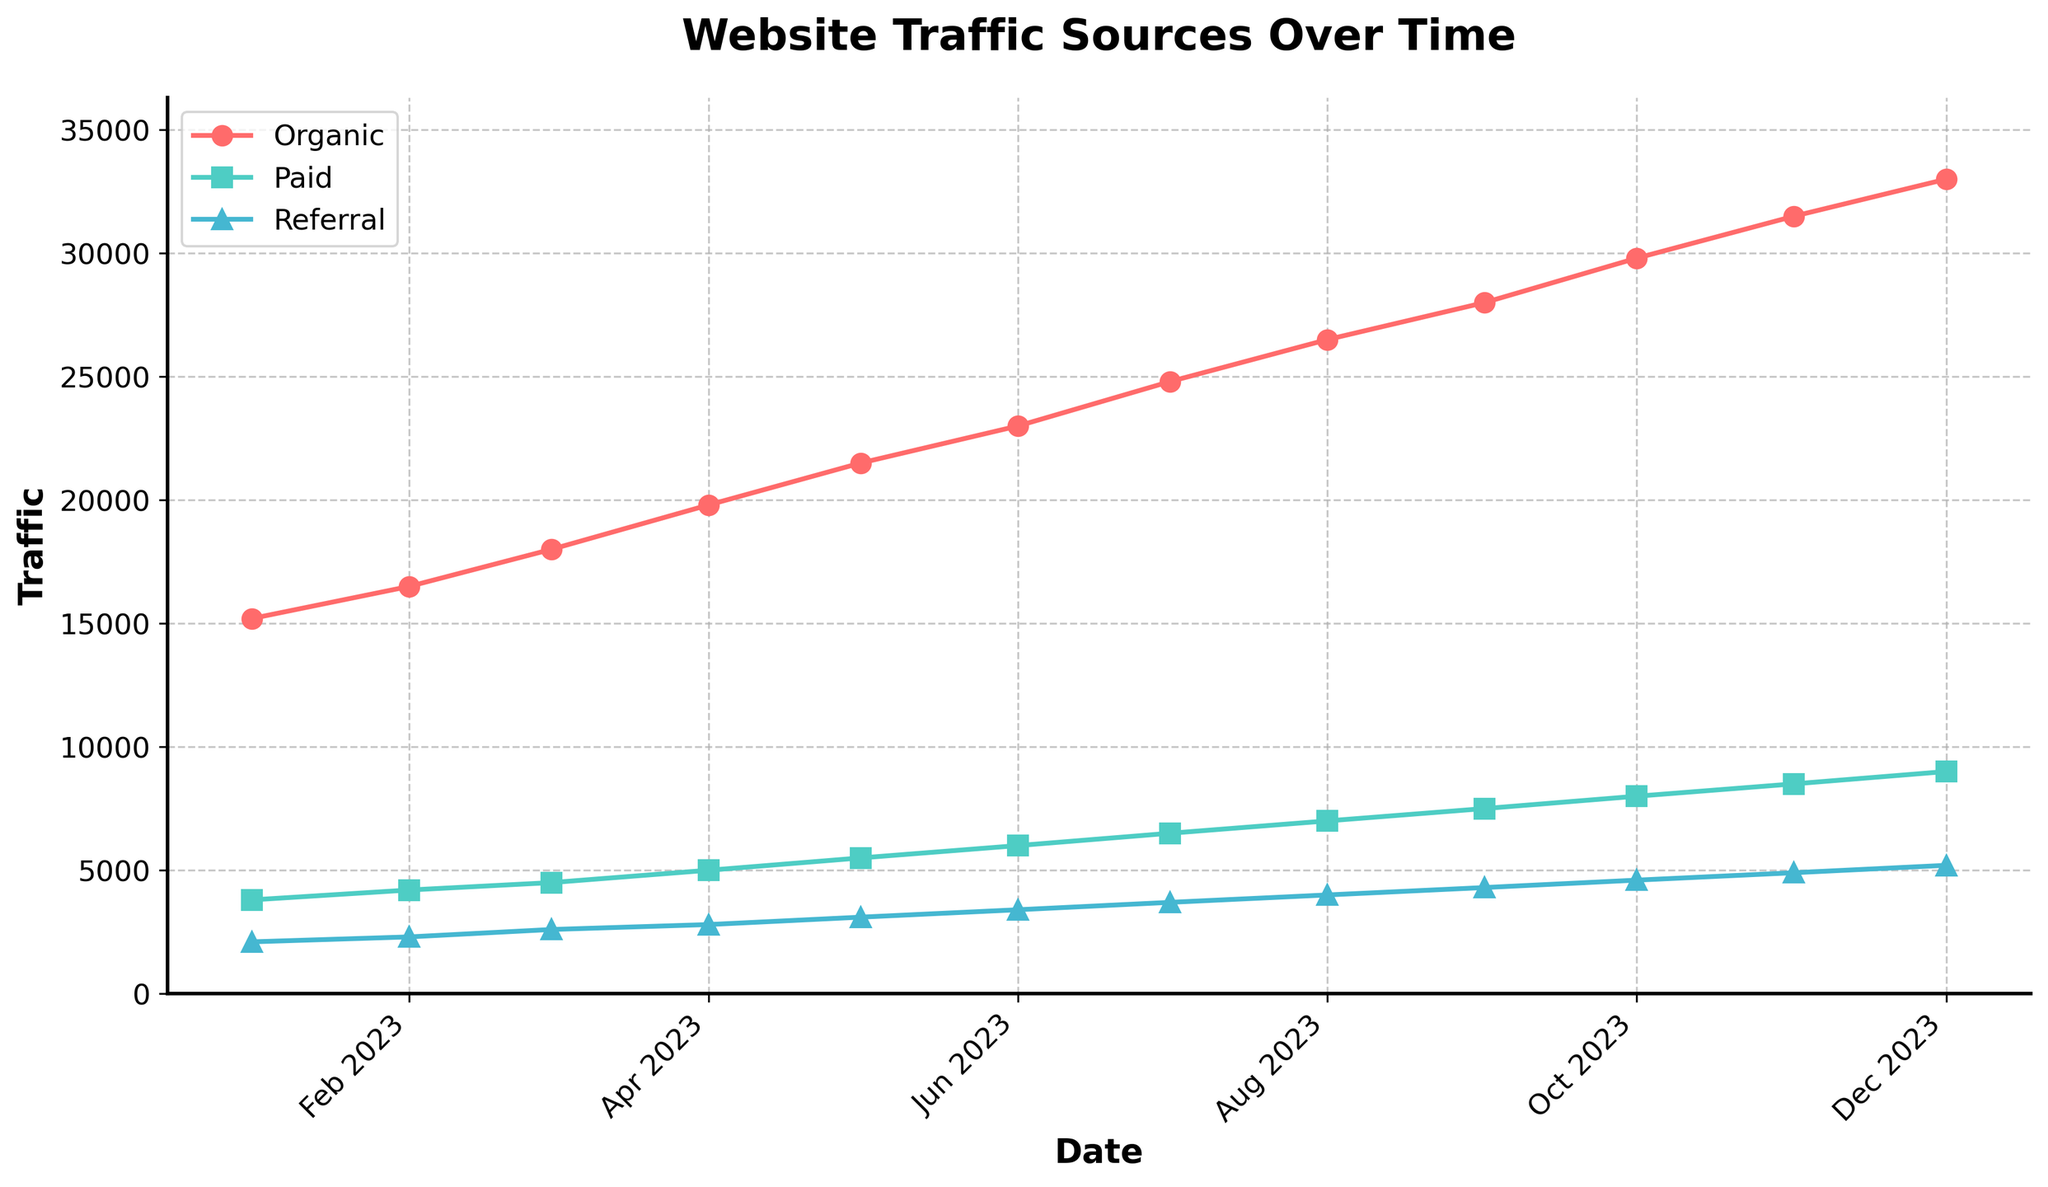Which traffic source had the highest value in December 2023? In December 2023, the highest value needs to be determined among Organic, Paid, and Referral traffic. By examining the data points for December on the plot, we see that Organic Traffic is at 33,000, Paid Traffic is at 9,000, and Referral Traffic is at 5,200. The highest value is for Organic Traffic.
Answer: Organic Traffic How has Organic Traffic trended over the year? To understand the trend of Organic Traffic over the year, observe the line that represents it. The line shows a consistent upward trend from January (15,200) to December (33,000), indicating a steady increase.
Answer: Increasing In which month was the increase in Paid Traffic the highest? Find the month-to-month increase in Paid Traffic by looking at the month-on-month values in the plot. The highest increase can be observed by comparing each month's values. Notably, between November (8,500) and December (9,000), the increase is 500.
Answer: December Which source of traffic had the smallest growth rate in May 2023 compared to January 2023? To find the smallest growth rate, calculate the difference for each traffic source between January and May, then divide by the January value. Organic Traffic increased by (21,500 - 15,200) / 15,200 = 41.4%; Paid Traffic increased by (5,500 - 3,800) / 3,800 = 44.7%; Referral Traffic increased by (3,100 - 2,100) / 2,100 = 47.6%. The smallest growth rate is for Organic Traffic.
Answer: Organic Traffic By how much did Referral Traffic exceed 4,000? Determine the month where Referral Traffic first exceeds 4,000 by examining the plotted points. Referral Traffic exceeds 4,000 in August 2023.
Answer: 700 Comparing April 2023, which traffic source had the closest value to Referral Traffic? In April 2023, refer to the plot values: Referral Traffic is 2,800, Organic Traffic is 19,800, and Paid Traffic is 5,000. Calculate the difference with Referral Traffic. The closest value to 2,800 is Paid Traffic (5,000 - 2,800 = 2,200).
Answer: Paid Traffic Which traffic source shows an almost linear increase throughout the year? To determine linearity, observe the consistency of spacing between data points for each traffic source. Organic Traffic appears to have a roughly linear increase as the intervals between each data point from January to December are consistent.
Answer: Organic Traffic What is the combined traffic from all sources in July 2023? Sum up the values of Organic, Paid, and Referral Traffic for July 2023: 24,800 (Organic) + 6,500 (Paid) + 3,700 (Referral).
Answer: 35,000 What is the difference in traffic between Organic and Paid sources in October 2023? Subtract the Paid Traffic value from the Organic Traffic value for October 2023: 29,800 (Organic) - 8,000 (Paid).
Answer: 21,800 